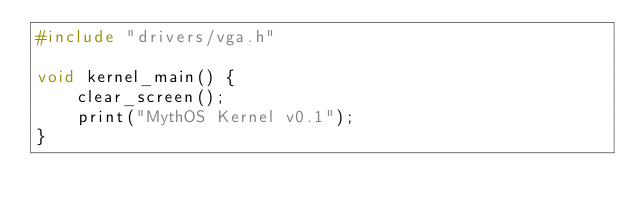<code> <loc_0><loc_0><loc_500><loc_500><_C_>#include "drivers/vga.h"

void kernel_main() {
    clear_screen();
    print("MythOS Kernel v0.1");
}</code> 